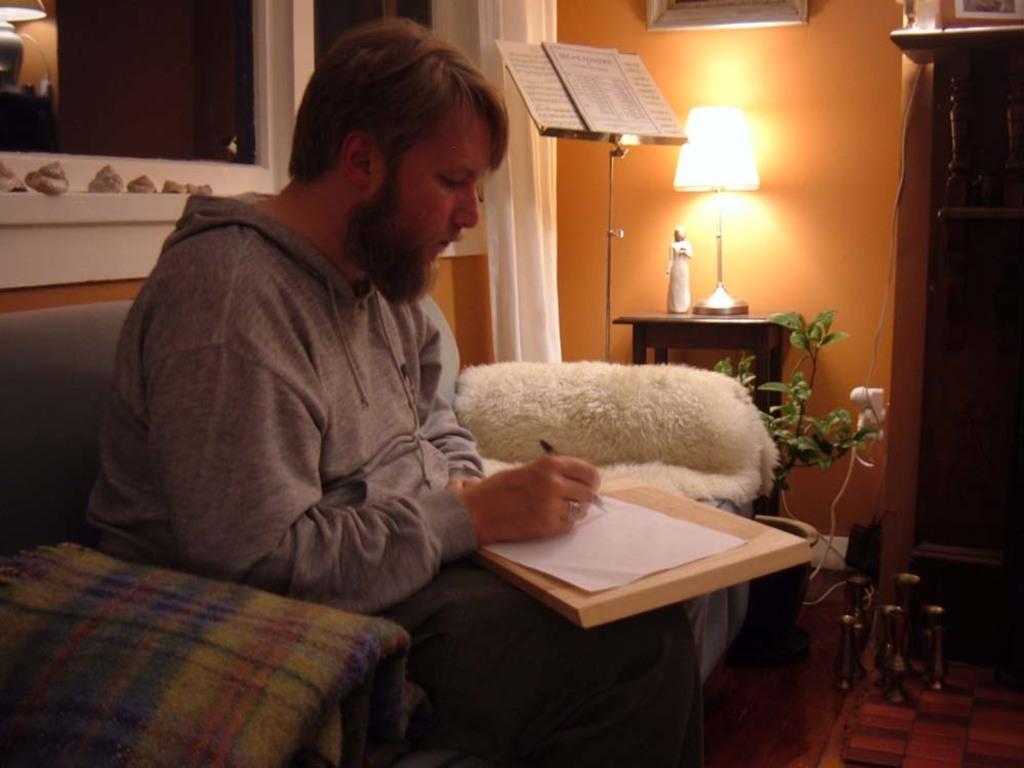Could you give a brief overview of what you see in this image? In this picture there is a man sitting on the chair. He is writing with a pen on a paper. There is a pad. There is a lamp. There is a book on the stand. There is a plant. There is a frame on the wall. There is a blanket. 